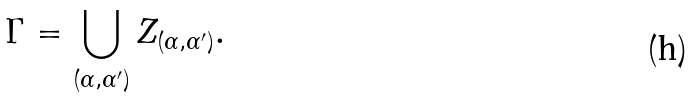<formula> <loc_0><loc_0><loc_500><loc_500>\Gamma = \bigcup _ { ( \alpha , \alpha ^ { \prime } ) } Z _ { ( \alpha , \alpha ^ { \prime } ) } .</formula> 